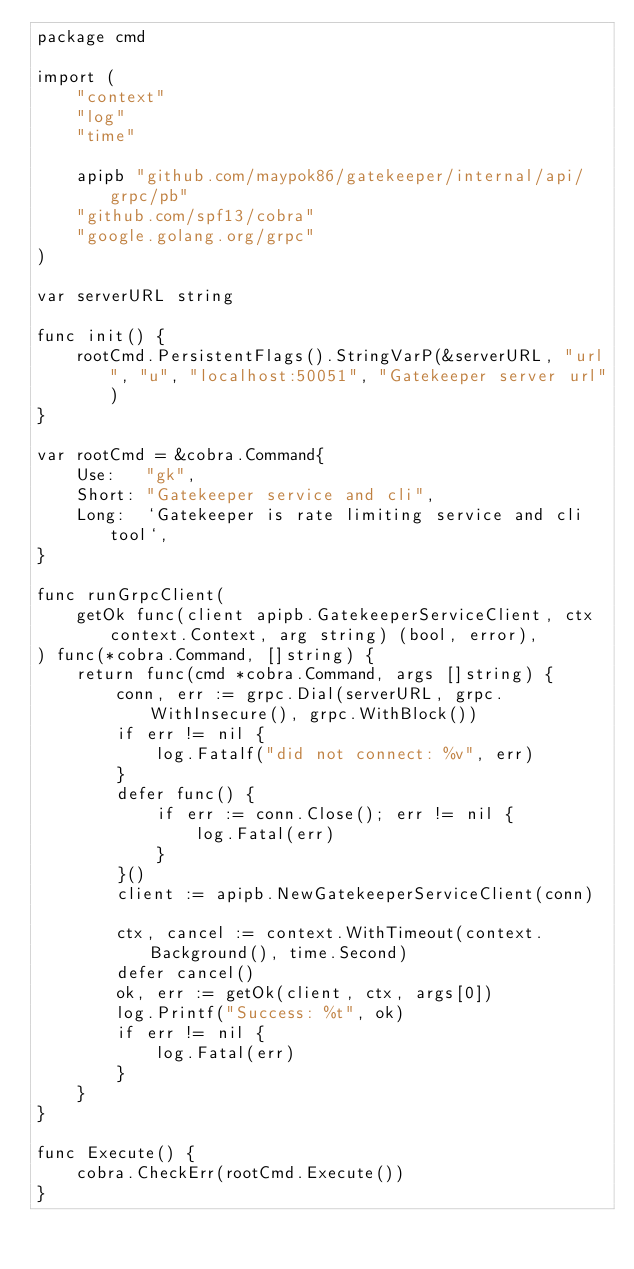<code> <loc_0><loc_0><loc_500><loc_500><_Go_>package cmd

import (
	"context"
	"log"
	"time"

	apipb "github.com/maypok86/gatekeeper/internal/api/grpc/pb"
	"github.com/spf13/cobra"
	"google.golang.org/grpc"
)

var serverURL string

func init() {
	rootCmd.PersistentFlags().StringVarP(&serverURL, "url", "u", "localhost:50051", "Gatekeeper server url")
}

var rootCmd = &cobra.Command{
	Use:   "gk",
	Short: "Gatekeeper service and cli",
	Long:  `Gatekeeper is rate limiting service and cli tool`,
}

func runGrpcClient(
	getOk func(client apipb.GatekeeperServiceClient, ctx context.Context, arg string) (bool, error),
) func(*cobra.Command, []string) {
	return func(cmd *cobra.Command, args []string) {
		conn, err := grpc.Dial(serverURL, grpc.WithInsecure(), grpc.WithBlock())
		if err != nil {
			log.Fatalf("did not connect: %v", err)
		}
		defer func() {
			if err := conn.Close(); err != nil {
				log.Fatal(err)
			}
		}()
		client := apipb.NewGatekeeperServiceClient(conn)

		ctx, cancel := context.WithTimeout(context.Background(), time.Second)
		defer cancel()
		ok, err := getOk(client, ctx, args[0])
		log.Printf("Success: %t", ok)
		if err != nil {
			log.Fatal(err)
		}
	}
}

func Execute() {
	cobra.CheckErr(rootCmd.Execute())
}
</code> 